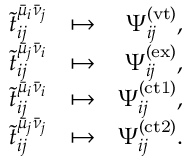<formula> <loc_0><loc_0><loc_500><loc_500>\begin{array} { r l r } { \tilde { t } _ { i j } ^ { \bar { \mu } _ { i } \bar { \nu } _ { j } } } & { \mapsto } & { \Psi _ { i j } ^ { ( v t ) } , } \\ { \tilde { t } _ { i j } ^ { \bar { \mu } _ { j } \bar { \nu } _ { i } } } & { \mapsto } & { \Psi _ { i j } ^ { ( e x ) } , } \\ { \tilde { t } _ { i j } ^ { \bar { \mu } _ { i } \bar { \nu } _ { i } } } & { \mapsto } & { \Psi _ { i j } ^ { ( c t 1 ) } , } \\ { \tilde { t } _ { i j } ^ { \bar { \mu } _ { j } \bar { \nu } _ { j } } } & { \mapsto } & { \Psi _ { i j } ^ { ( c t 2 ) } . } \end{array}</formula> 